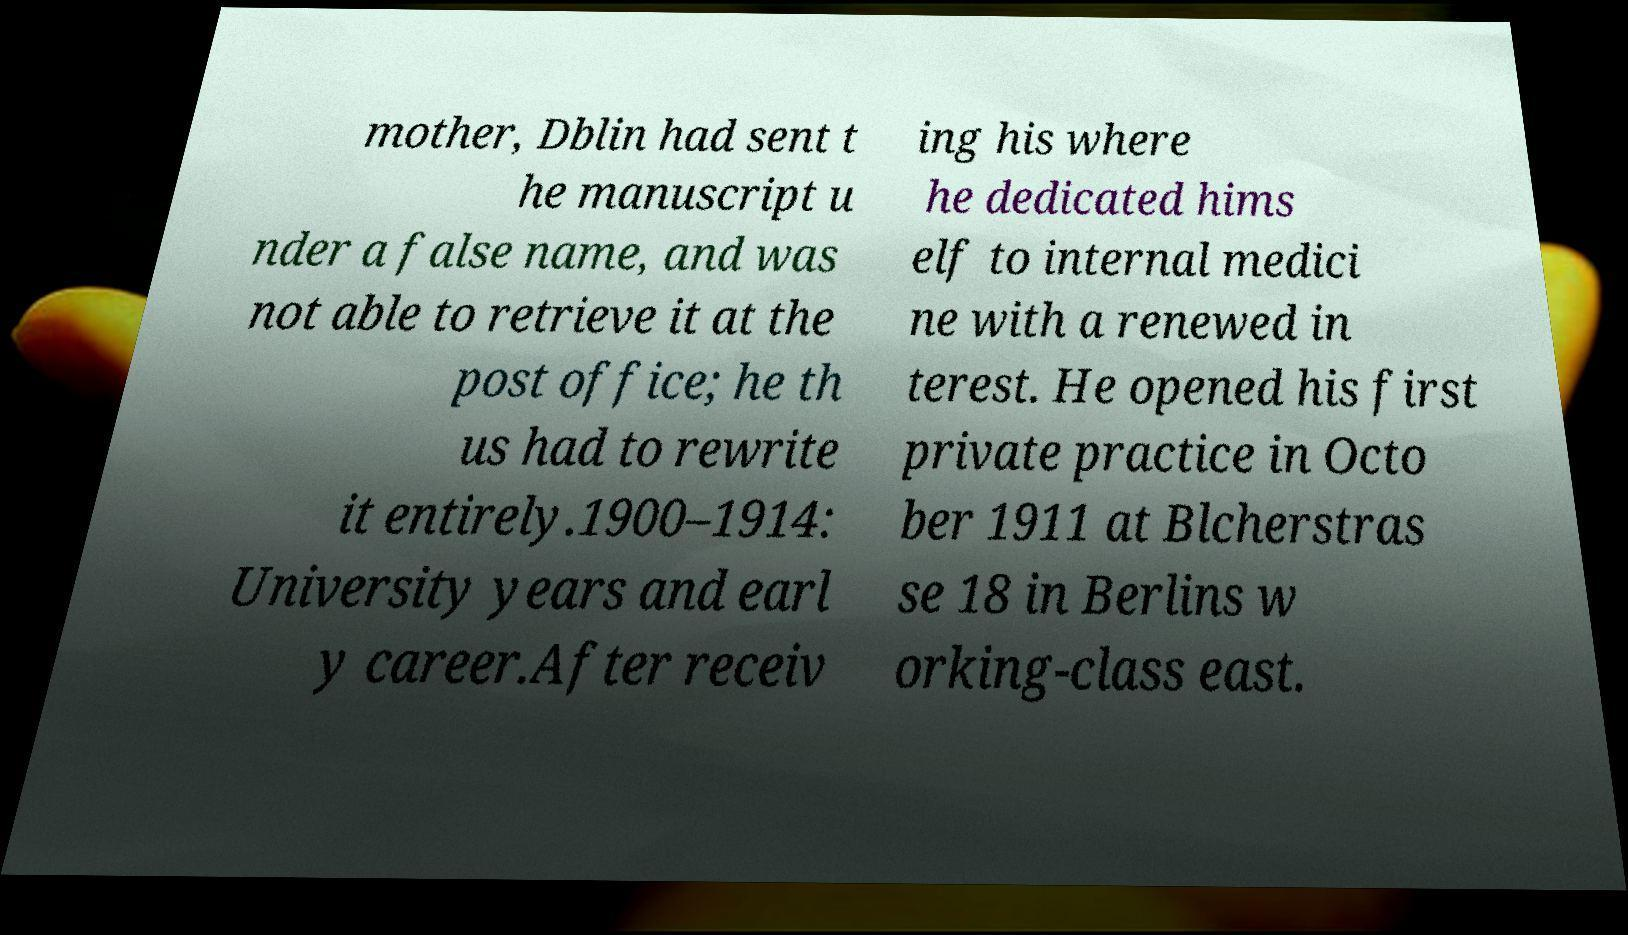Please identify and transcribe the text found in this image. mother, Dblin had sent t he manuscript u nder a false name, and was not able to retrieve it at the post office; he th us had to rewrite it entirely.1900–1914: University years and earl y career.After receiv ing his where he dedicated hims elf to internal medici ne with a renewed in terest. He opened his first private practice in Octo ber 1911 at Blcherstras se 18 in Berlins w orking-class east. 